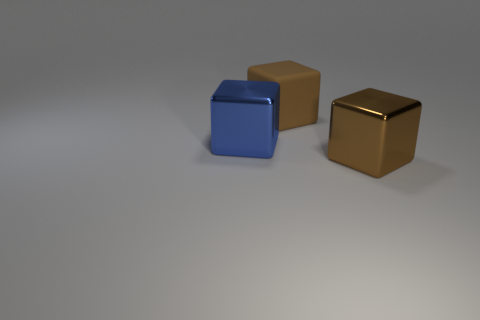There is a large brown cube that is behind the metal object to the left of the brown metallic object; are there any large brown rubber blocks that are left of it?
Provide a succinct answer. No. What is the object behind the big blue shiny object made of?
Offer a terse response. Rubber. Is the blue metallic thing the same size as the brown rubber thing?
Make the answer very short. Yes. There is a cube that is right of the blue thing and in front of the big brown matte object; what color is it?
Your response must be concise. Brown. What is the shape of the big object that is the same material as the large blue cube?
Your answer should be compact. Cube. What number of things are both in front of the matte block and to the right of the blue metallic object?
Your answer should be compact. 1. Are there any brown metallic cubes in front of the blue object?
Offer a very short reply. Yes. There is a brown thing that is behind the brown shiny thing; is its shape the same as the big thing that is to the right of the rubber object?
Provide a succinct answer. Yes. How many objects are either large blue things or big shiny blocks left of the big brown metal block?
Your answer should be very brief. 1. How many other things are there of the same shape as the large rubber thing?
Your answer should be very brief. 2. 